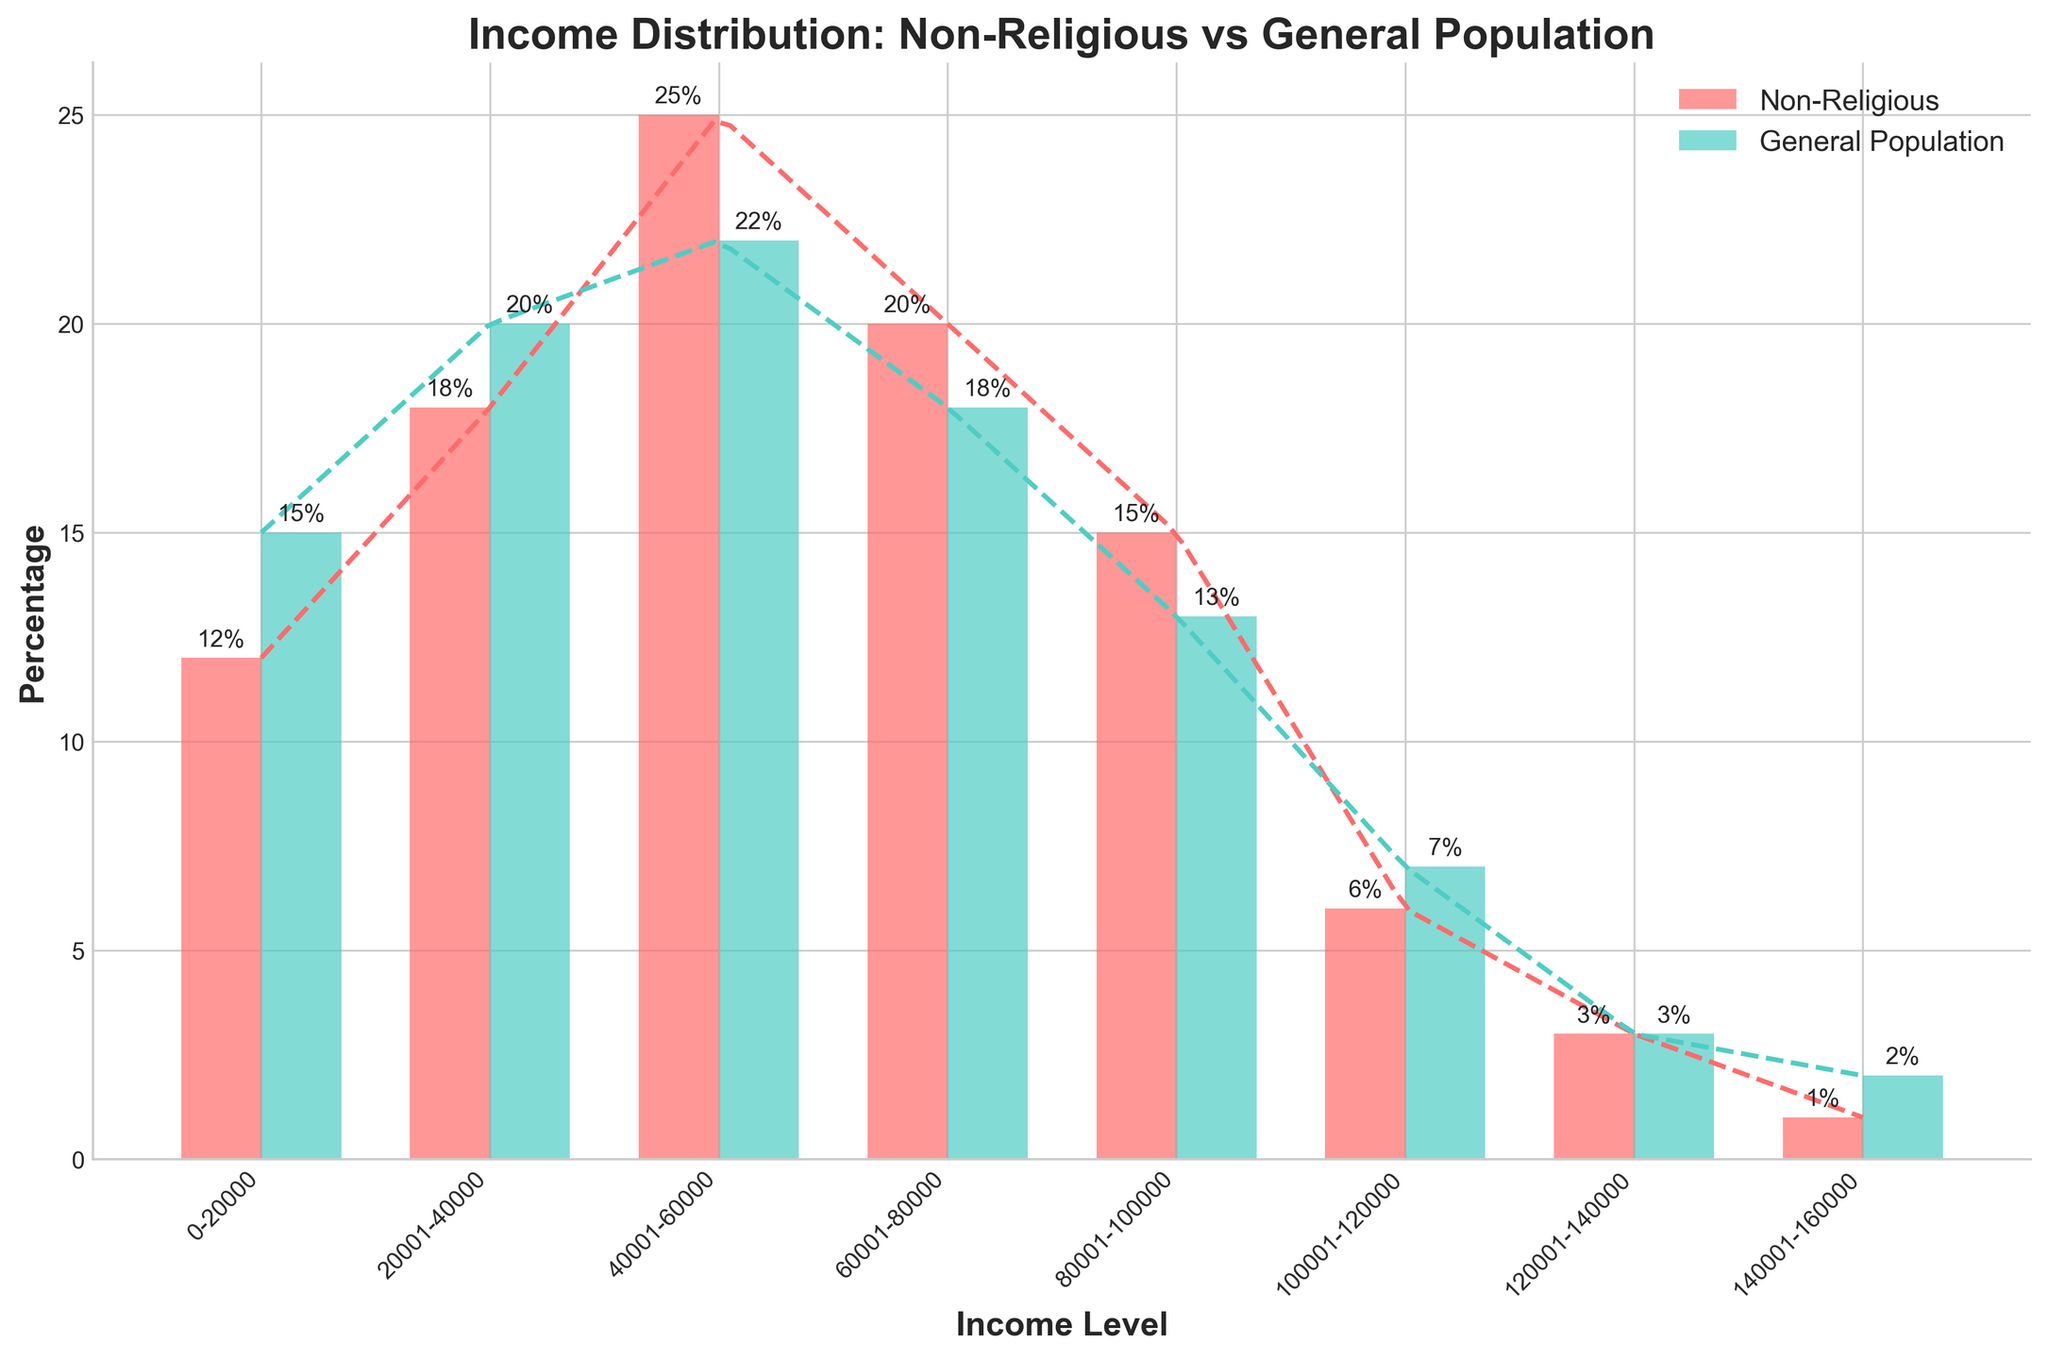What's the title of the figure? The title is written at the top of the figure. It reads "Income Distribution: Non-Religious vs General Population".
Answer: Income Distribution: Non-Religious vs General Population What does the x-axis represent? The x-axis labels, which are rotated 45 degrees, show different income ranges.
Answer: Income Level How many income levels do the data cover? By counting the distinct labels on the x-axis, we see there are 8 income levels.
Answer: 8 Which group has a higher percentage in the $20,001-$40,000 income level? The bar for the $20,001-$40,000 income level representing the General Population is slightly taller than the one for Non-Religious, indicating a higher percentage.
Answer: General Population How does the distribution of income levels for Non-Religious individuals compare to the General Population? Non-Religious individuals have a higher percentage in the middle income brackets ($40,001-$60,000 and $60,001-$80,000), while the General Population has a more even spread across various income levels and a higher lower income bracket ($0-$20,000).
Answer: Non-Religious individuals are concentrated in the middle-income brackets, General Population is more evenly spread What is the percentage difference between Non-Religious and General Population for the $0-$20,000 income level? Non-Religious have 12%, and General Population have 15%. The difference is 15% - 12% = 3%.
Answer: 3% At which income level do the Non-Religious individuals have the highest percentage, and what is it? The highest bar for Non-Religious is at the $40,001-$60,000 level, which is 25%.
Answer: $40,001-$60,000, 25% Which income level has the smallest percentage for both groups, and what are these percentages? The smallest percentages for both groups are at the $140,001-$160,000 income level. Non-Religious have 1%, and General Population have 2%.
Answer: $140,001-$160,000, 1% (Non-Religious), 2% (General Population) How do the KDE curves for Non-Religious and General Population compare? The KDE curve for Non-Religious peaks around the middle income levels, while the General Population's KDE curve is more evenly distributed but still has a noticeable peak somewhere. The differences indicate that Non-Religious income is more concentrated in the median ranges compared to the General Population.
Answer: Non-Religious peak in the middle, General Population more even What does the color of the bars indicate? The legend shows that the red bars represent Non-Religious individuals, and turquoise bars represent the General Population.
Answer: Red for Non-Religious, turquoise for General Population 